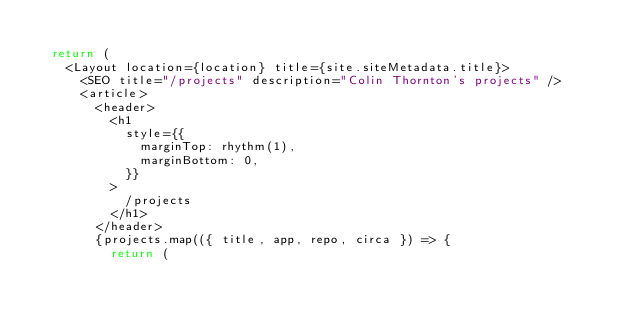Convert code to text. <code><loc_0><loc_0><loc_500><loc_500><_JavaScript_>
  return (
    <Layout location={location} title={site.siteMetadata.title}>
      <SEO title="/projects" description="Colin Thornton's projects" />
      <article>
        <header>
          <h1
            style={{
              marginTop: rhythm(1),
              marginBottom: 0,
            }}
          >
            /projects
          </h1>
        </header>
        {projects.map(({ title, app, repo, circa }) => {
          return (</code> 